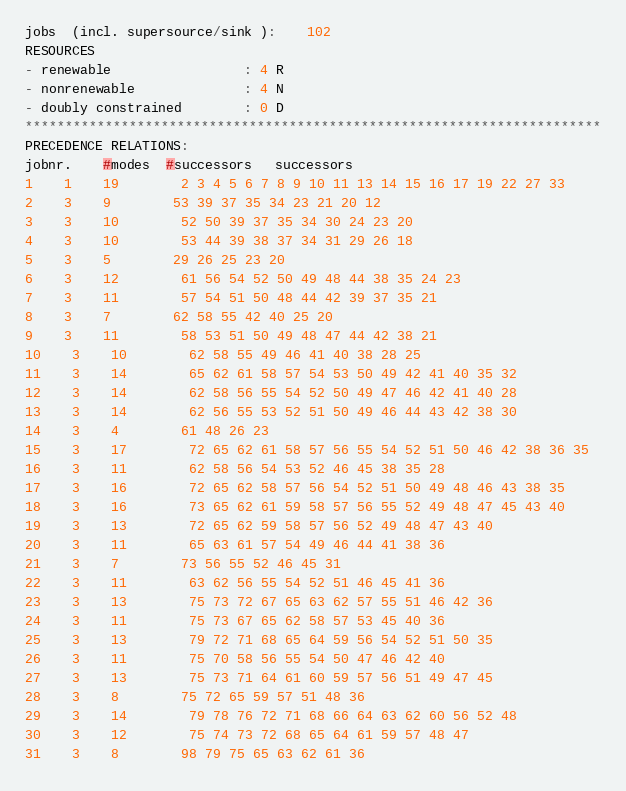Convert code to text. <code><loc_0><loc_0><loc_500><loc_500><_ObjectiveC_>jobs  (incl. supersource/sink ):	102
RESOURCES
- renewable                 : 4 R
- nonrenewable              : 4 N
- doubly constrained        : 0 D
************************************************************************
PRECEDENCE RELATIONS:
jobnr.    #modes  #successors   successors
1	1	19		2 3 4 5 6 7 8 9 10 11 13 14 15 16 17 19 22 27 33 
2	3	9		53 39 37 35 34 23 21 20 12 
3	3	10		52 50 39 37 35 34 30 24 23 20 
4	3	10		53 44 39 38 37 34 31 29 26 18 
5	3	5		29 26 25 23 20 
6	3	12		61 56 54 52 50 49 48 44 38 35 24 23 
7	3	11		57 54 51 50 48 44 42 39 37 35 21 
8	3	7		62 58 55 42 40 25 20 
9	3	11		58 53 51 50 49 48 47 44 42 38 21 
10	3	10		62 58 55 49 46 41 40 38 28 25 
11	3	14		65 62 61 58 57 54 53 50 49 42 41 40 35 32 
12	3	14		62 58 56 55 54 52 50 49 47 46 42 41 40 28 
13	3	14		62 56 55 53 52 51 50 49 46 44 43 42 38 30 
14	3	4		61 48 26 23 
15	3	17		72 65 62 61 58 57 56 55 54 52 51 50 46 42 38 36 35 
16	3	11		62 58 56 54 53 52 46 45 38 35 28 
17	3	16		72 65 62 58 57 56 54 52 51 50 49 48 46 43 38 35 
18	3	16		73 65 62 61 59 58 57 56 55 52 49 48 47 45 43 40 
19	3	13		72 65 62 59 58 57 56 52 49 48 47 43 40 
20	3	11		65 63 61 57 54 49 46 44 41 38 36 
21	3	7		73 56 55 52 46 45 31 
22	3	11		63 62 56 55 54 52 51 46 45 41 36 
23	3	13		75 73 72 67 65 63 62 57 55 51 46 42 36 
24	3	11		75 73 67 65 62 58 57 53 45 40 36 
25	3	13		79 72 71 68 65 64 59 56 54 52 51 50 35 
26	3	11		75 70 58 56 55 54 50 47 46 42 40 
27	3	13		75 73 71 64 61 60 59 57 56 51 49 47 45 
28	3	8		75 72 65 59 57 51 48 36 
29	3	14		79 78 76 72 71 68 66 64 63 62 60 56 52 48 
30	3	12		75 74 73 72 68 65 64 61 59 57 48 47 
31	3	8		98 79 75 65 63 62 61 36 </code> 